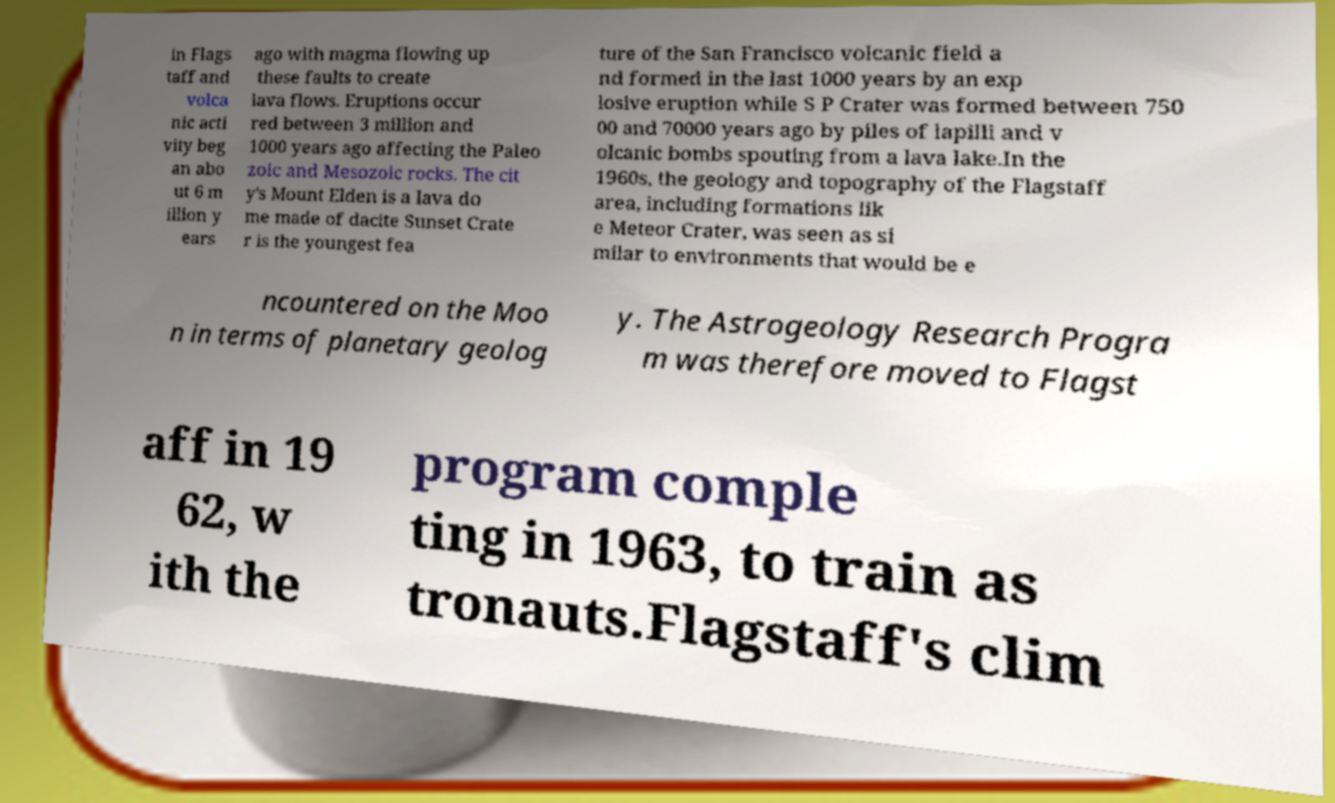Can you accurately transcribe the text from the provided image for me? in Flags taff and volca nic acti vity beg an abo ut 6 m illion y ears ago with magma flowing up these faults to create lava flows. Eruptions occur red between 3 million and 1000 years ago affecting the Paleo zoic and Mesozoic rocks. The cit y's Mount Elden is a lava do me made of dacite Sunset Crate r is the youngest fea ture of the San Francisco volcanic field a nd formed in the last 1000 years by an exp losive eruption while S P Crater was formed between 750 00 and 70000 years ago by piles of lapilli and v olcanic bombs spouting from a lava lake.In the 1960s, the geology and topography of the Flagstaff area, including formations lik e Meteor Crater, was seen as si milar to environments that would be e ncountered on the Moo n in terms of planetary geolog y. The Astrogeology Research Progra m was therefore moved to Flagst aff in 19 62, w ith the program comple ting in 1963, to train as tronauts.Flagstaff's clim 